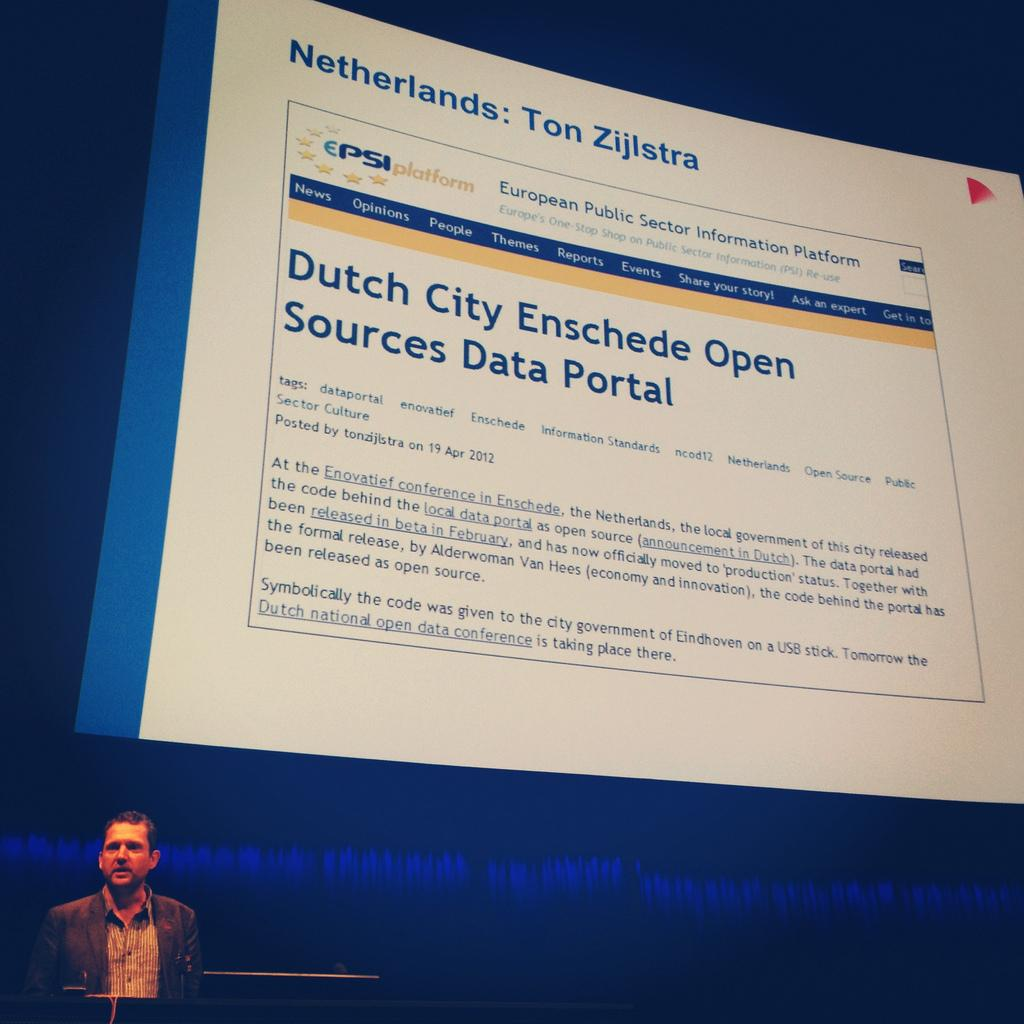Who or what is present in the image? There is a person in the image. What can be observed about the person's attire? The person is wearing clothes. What additional object or feature is visible in the image? There is a projected screen visible in the image. What information can be gathered from the projected screen? There is text written on the projected screen. How does the person in the image feel about the dirt on the canvas? There is no dirt or canvas present in the image, so it is not possible to determine how the person feels about them. 